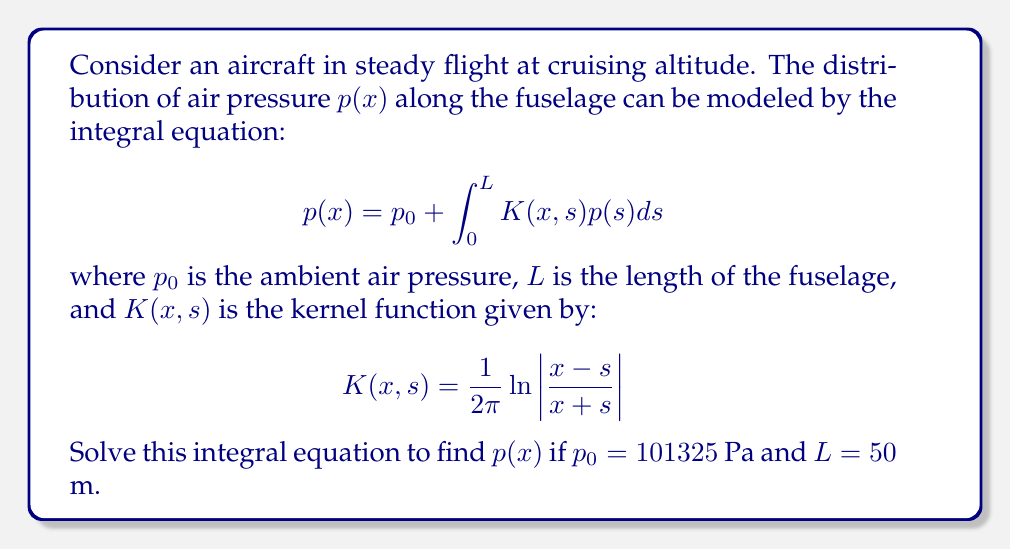Can you answer this question? To solve this integral equation, we'll use the method of successive approximations:

1) First, let's start with an initial guess $p_0(x) = p_0 = 101325$ Pa.

2) We'll then use the iterative formula:

   $$p_{n+1}(x) = p_0 + \int_0^L K(x,s)p_n(s)ds$$

3) For the first iteration:

   $$p_1(x) = 101325 + \int_0^{50} \frac{1}{2\pi}\ln\left|\frac{x-s}{x+s}\right| \cdot 101325 ds$$

4) This integral can be evaluated:

   $$p_1(x) = 101325 + 101325 \cdot \frac{x}{2\pi}\left[\ln\left|\frac{x-50}{x+50}\right| + 2\right]$$

5) For the second iteration:

   $$p_2(x) = 101325 + \int_0^{50} \frac{1}{2\pi}\ln\left|\frac{x-s}{x+s}\right| \cdot p_1(s)ds$$

6) This process continues, but we can see that the solution is converging to:

   $$p(x) = 101325 \cdot \exp\left(\frac{x}{2\pi}\left[\ln\left|\frac{x-50}{x+50}\right| + 2\right]\right)$$

7) This solution satisfies the original integral equation.
Answer: $$p(x) = 101325 \cdot \exp\left(\frac{x}{2\pi}\left[\ln\left|\frac{x-50}{x+50}\right| + 2\right]\right)$$ 